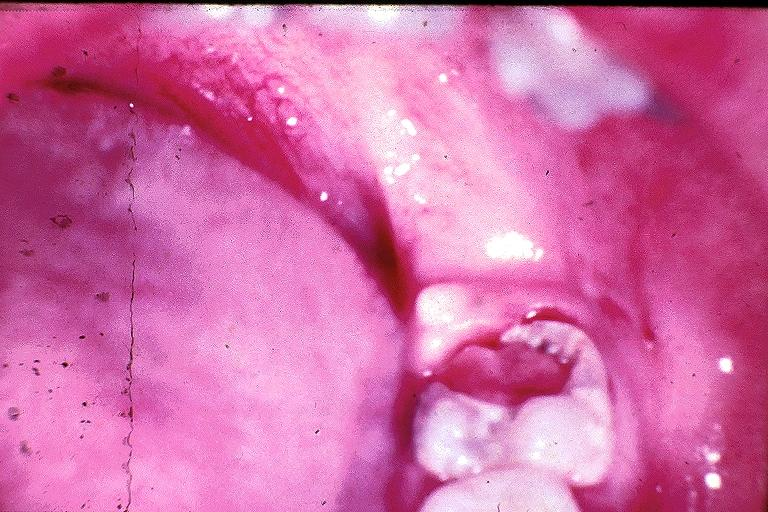does this image show chronic hyperplastic pulpitis?
Answer the question using a single word or phrase. Yes 